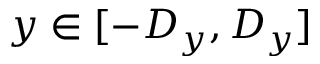<formula> <loc_0><loc_0><loc_500><loc_500>y \in [ - D _ { y } , D _ { y } ]</formula> 